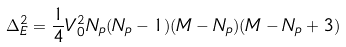Convert formula to latex. <formula><loc_0><loc_0><loc_500><loc_500>\Delta _ { E } ^ { 2 } = \frac { 1 } { 4 } V _ { 0 } ^ { 2 } N _ { p } ( N _ { p } - 1 ) ( M - N _ { p } ) ( M - N _ { p } + 3 )</formula> 